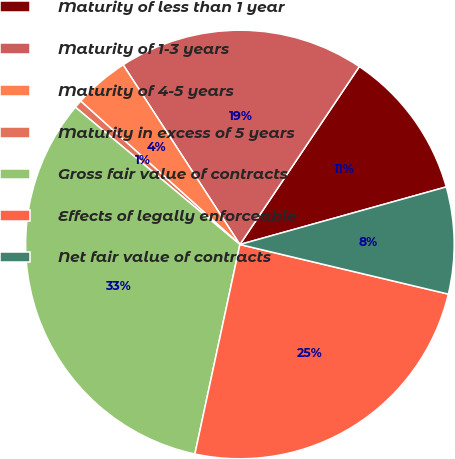<chart> <loc_0><loc_0><loc_500><loc_500><pie_chart><fcel>Maturity of less than 1 year<fcel>Maturity of 1-3 years<fcel>Maturity of 4-5 years<fcel>Maturity in excess of 5 years<fcel>Gross fair value of contracts<fcel>Effects of legally enforceable<fcel>Net fair value of contracts<nl><fcel>11.26%<fcel>18.58%<fcel>4.16%<fcel>0.6%<fcel>32.7%<fcel>24.65%<fcel>8.05%<nl></chart> 